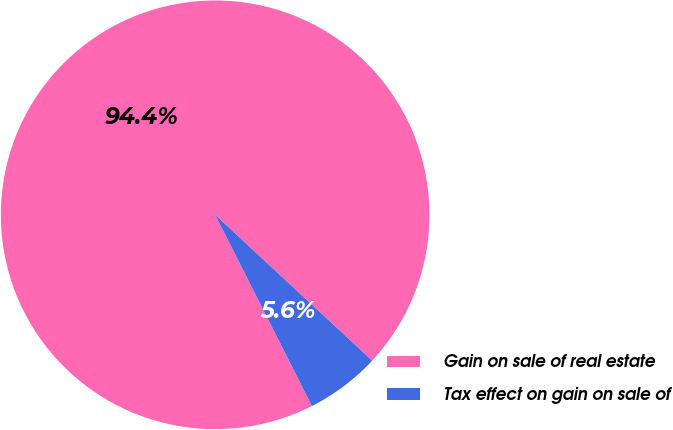Convert chart. <chart><loc_0><loc_0><loc_500><loc_500><pie_chart><fcel>Gain on sale of real estate<fcel>Tax effect on gain on sale of<nl><fcel>94.37%<fcel>5.63%<nl></chart> 